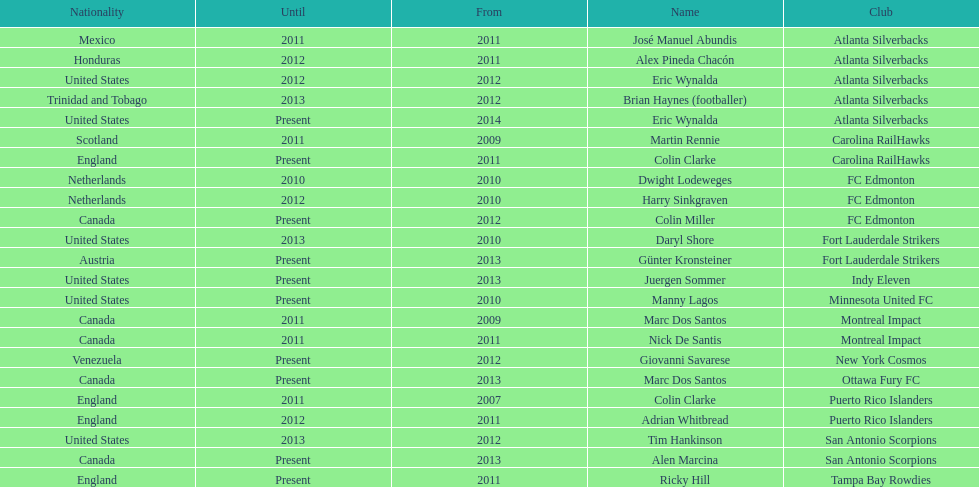Marc dos santos started as coach the same year as what other coach? Martin Rennie. 